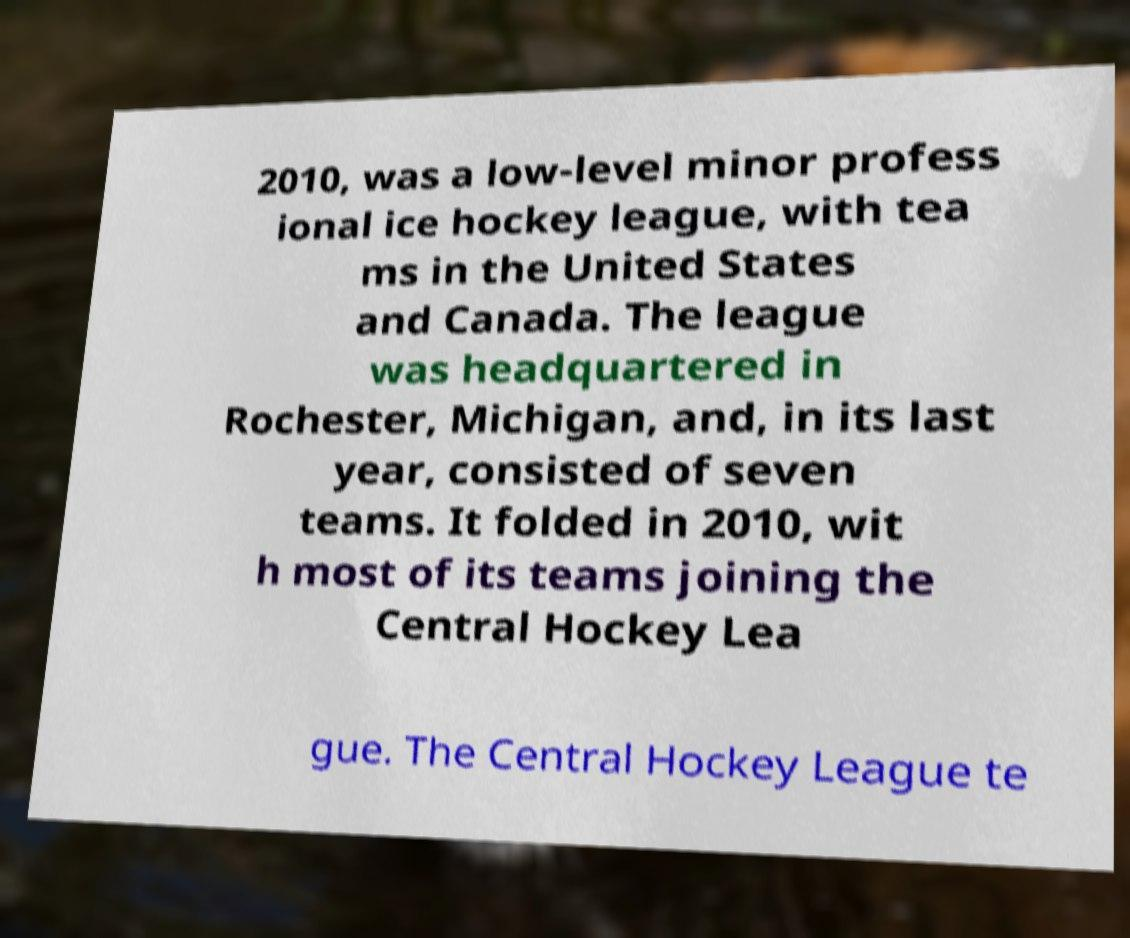Please identify and transcribe the text found in this image. 2010, was a low-level minor profess ional ice hockey league, with tea ms in the United States and Canada. The league was headquartered in Rochester, Michigan, and, in its last year, consisted of seven teams. It folded in 2010, wit h most of its teams joining the Central Hockey Lea gue. The Central Hockey League te 